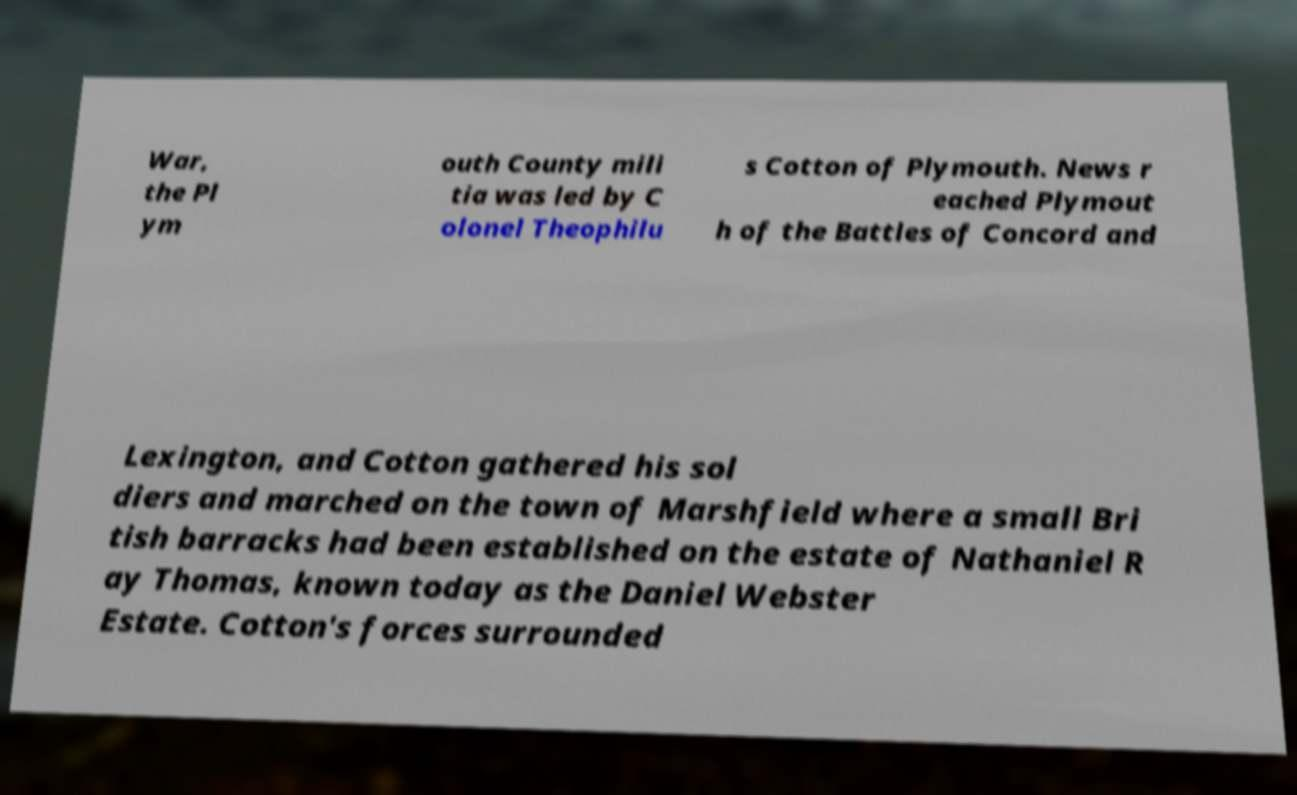Can you accurately transcribe the text from the provided image for me? War, the Pl ym outh County mili tia was led by C olonel Theophilu s Cotton of Plymouth. News r eached Plymout h of the Battles of Concord and Lexington, and Cotton gathered his sol diers and marched on the town of Marshfield where a small Bri tish barracks had been established on the estate of Nathaniel R ay Thomas, known today as the Daniel Webster Estate. Cotton's forces surrounded 